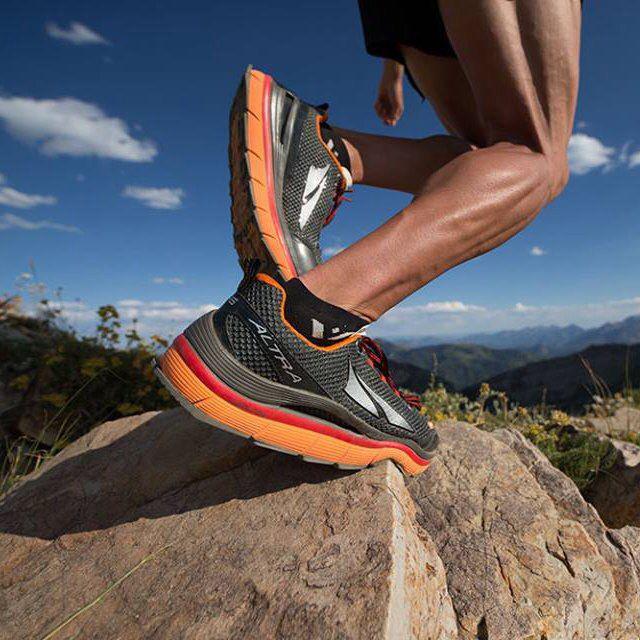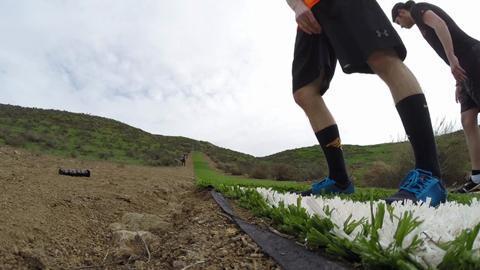The first image is the image on the left, the second image is the image on the right. Considering the images on both sides, is "One of the runners is running on a road and the other is running by a body of water." valid? Answer yes or no. No. The first image is the image on the left, the second image is the image on the right. Assess this claim about the two images: "One person is running leftward in front of a body of water.". Correct or not? Answer yes or no. No. 